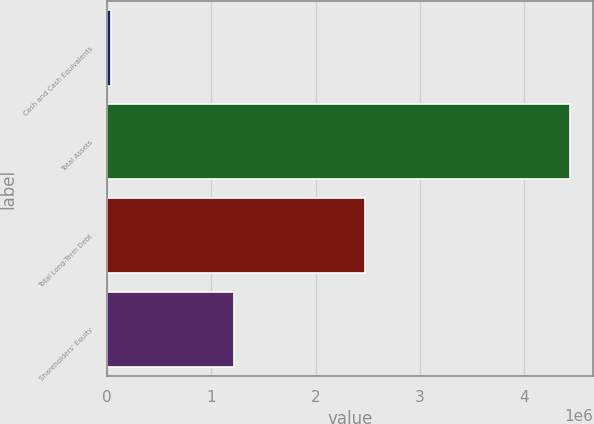<chart> <loc_0><loc_0><loc_500><loc_500><bar_chart><fcel>Cash and Cash Equivalents<fcel>Total Assets<fcel>Total Long-Term Debt<fcel>Shareholders' Equity<nl><fcel>31942<fcel>4.44239e+06<fcel>2.47802e+06<fcel>1.21857e+06<nl></chart> 